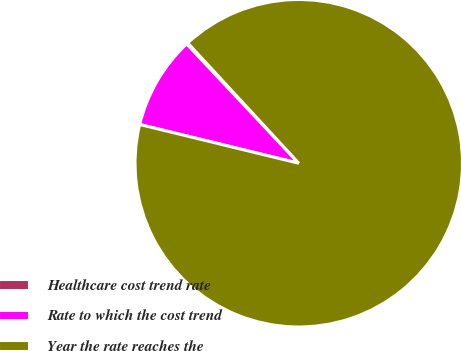Convert chart. <chart><loc_0><loc_0><loc_500><loc_500><pie_chart><fcel>Healthcare cost trend rate<fcel>Rate to which the cost trend<fcel>Year the rate reaches the<nl><fcel>0.14%<fcel>9.19%<fcel>90.68%<nl></chart> 